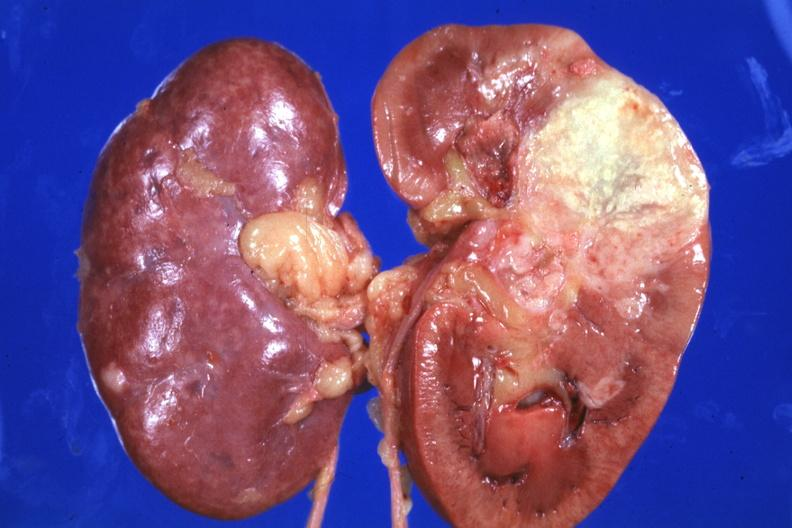does this image show single large lesion quite good?
Answer the question using a single word or phrase. Yes 